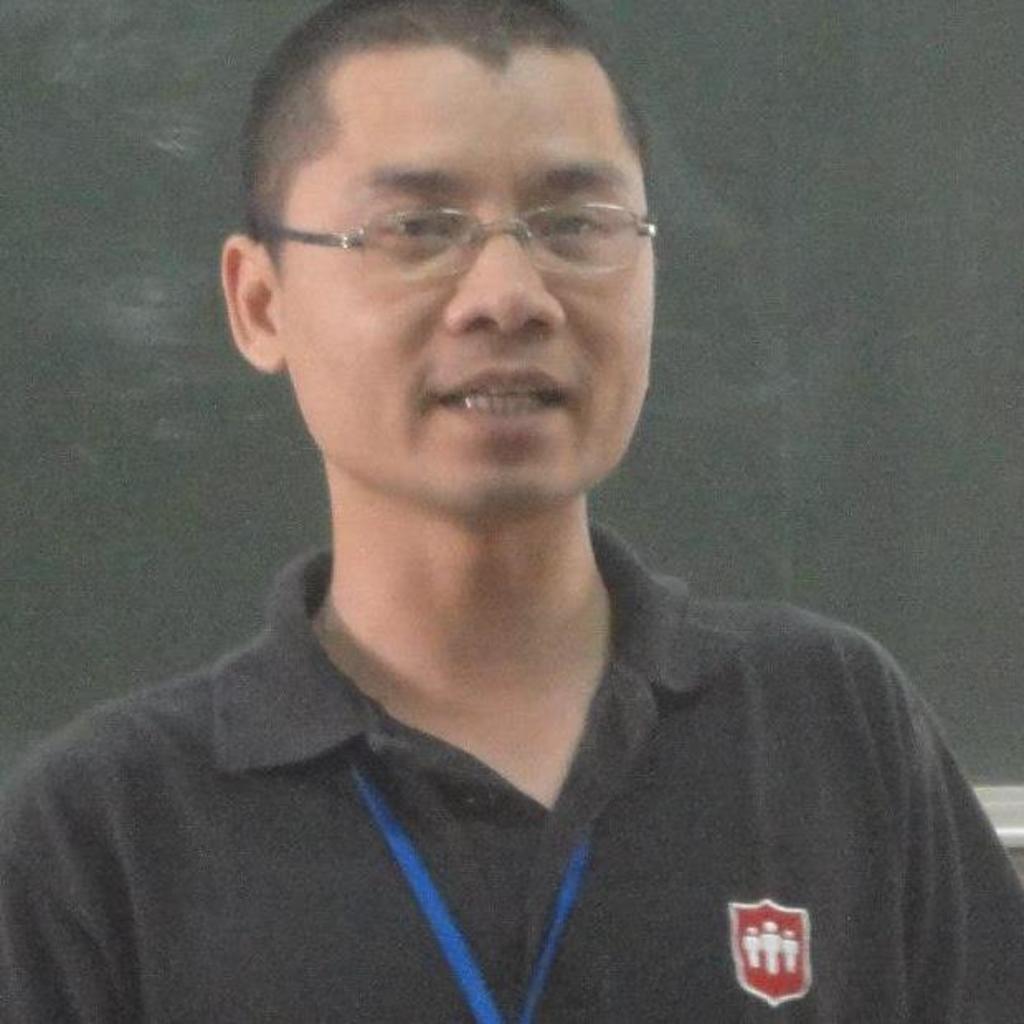Please provide a concise description of this image. In the image we can see there is a man and he is wearing spectacles. 